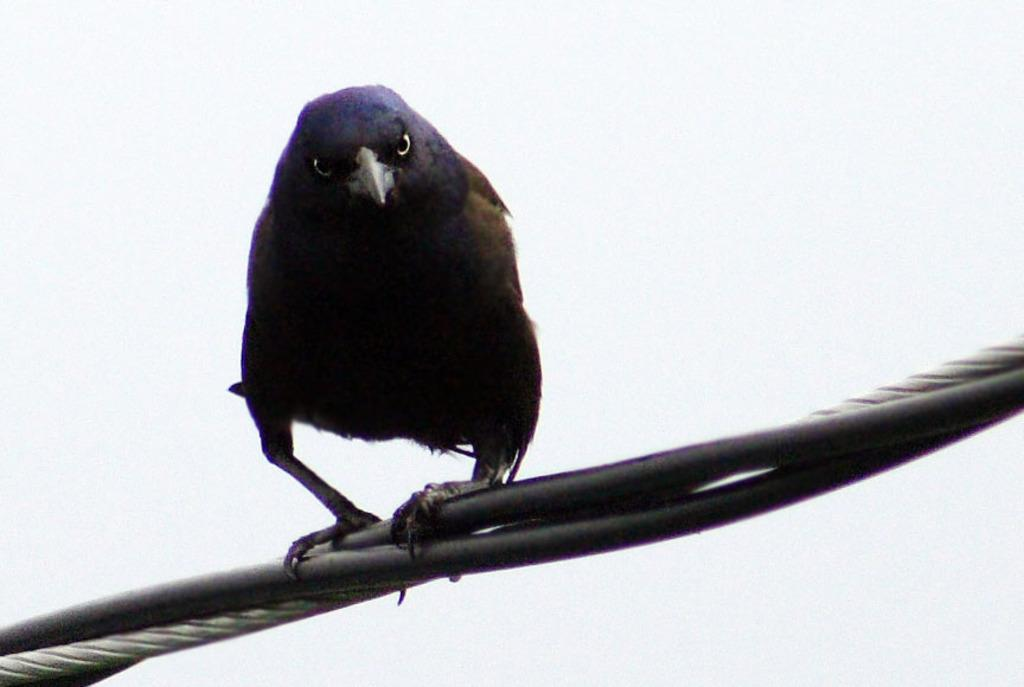What is the main subject of the image? There is a bird in the middle of the image. What can be seen at the bottom of the image? There are wires at the bottom of the image. What is the setting or location depicted in the background of the image? The background of the image appears to be a plane. How many grapes are being shared by the family in the image? There is no family or grapes present in the image; it features a bird and wires. What is the source of shame for the person in the image? There is no person or indication of shame in the image; it features a bird and wires. 